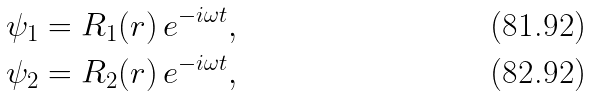<formula> <loc_0><loc_0><loc_500><loc_500>\psi _ { 1 } = R _ { 1 } ( r ) \, e ^ { - i \omega t } , \\ \psi _ { 2 } = R _ { 2 } ( r ) \, e ^ { - i \omega t } ,</formula> 